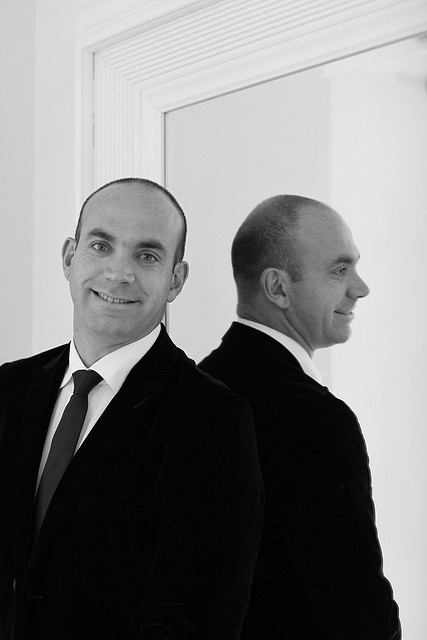Describe the objects in this image and their specific colors. I can see people in lightgray, black, darkgray, and dimgray tones, people in lightgray, black, and gray tones, and tie in lightgray, black, and gray tones in this image. 